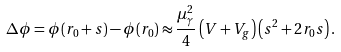Convert formula to latex. <formula><loc_0><loc_0><loc_500><loc_500>\Delta \phi = \phi ( r _ { 0 } + s ) - \phi ( r _ { 0 } ) \approx \frac { \mu _ { \gamma } ^ { 2 } } { 4 } \left ( V + V _ { g } \right ) \left ( s ^ { 2 } + 2 r _ { 0 } s \right ) .</formula> 